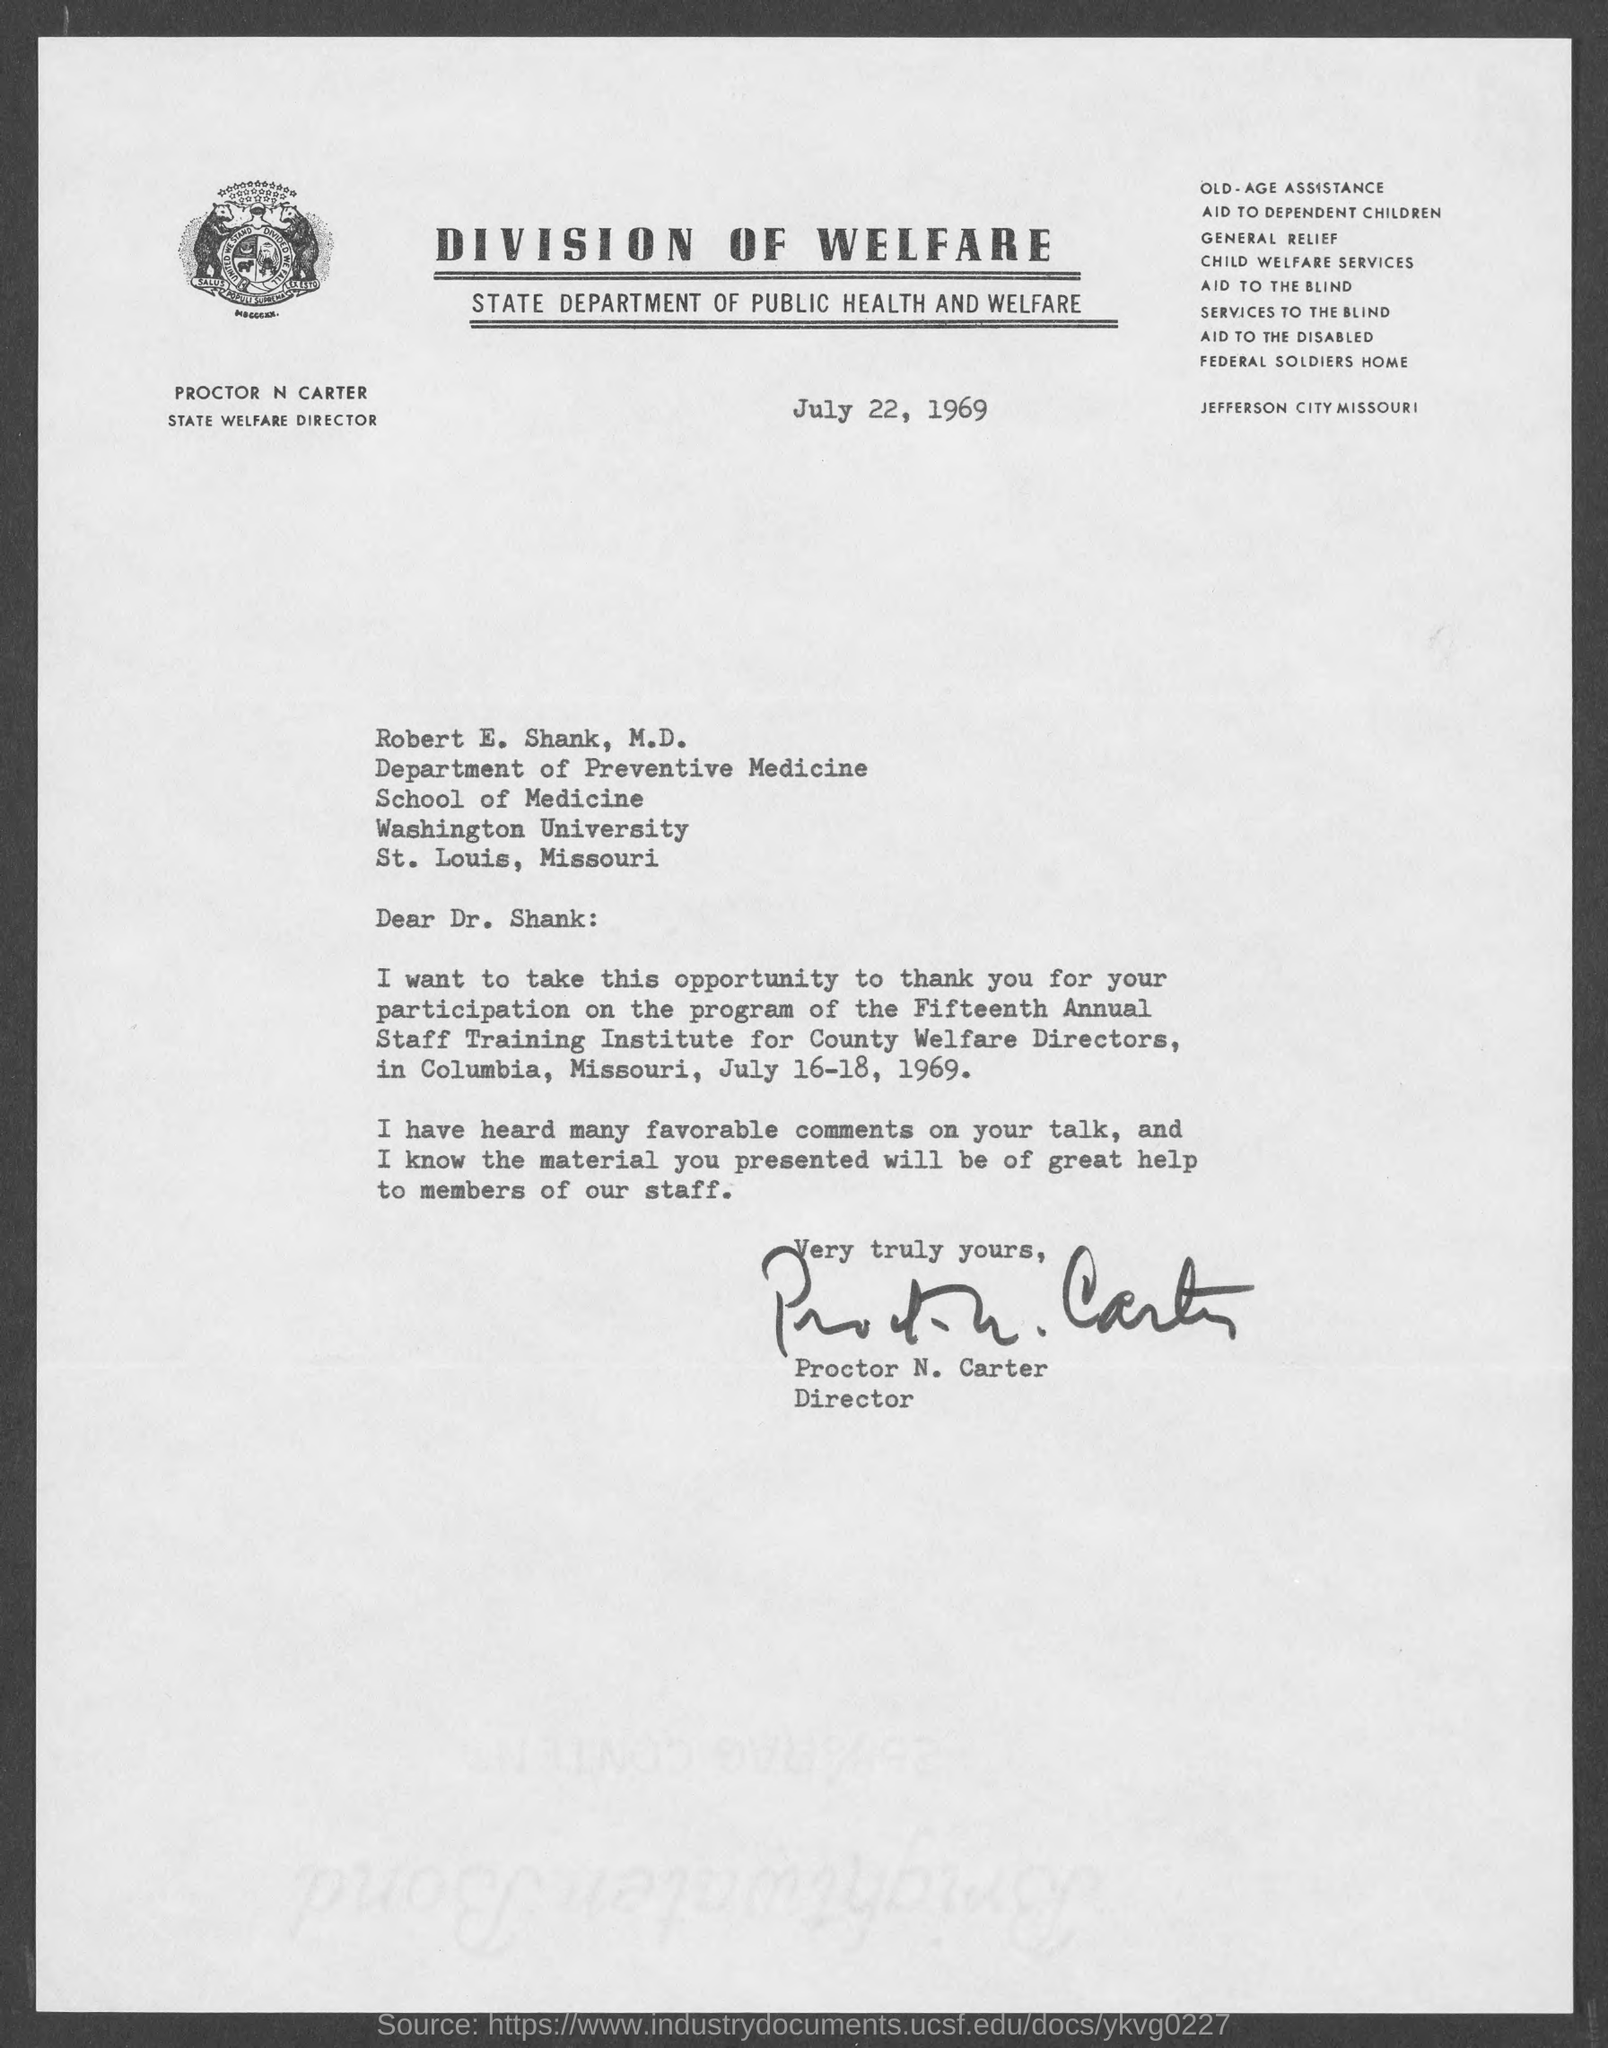When was the program of the Fifteenth Annual Staff Training Institute for County Welfare Directors held?
Ensure brevity in your answer.  July 16-18, 1969. Who has signed this letter?
Your response must be concise. Proctor N. Carter. What is the issued date of this letter?
Your response must be concise. July 22, 1969. 